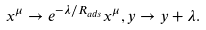<formula> <loc_0><loc_0><loc_500><loc_500>x ^ { \mu } \rightarrow e ^ { - \lambda / R _ { a d s } } x ^ { \mu } , y \rightarrow y + \lambda .</formula> 